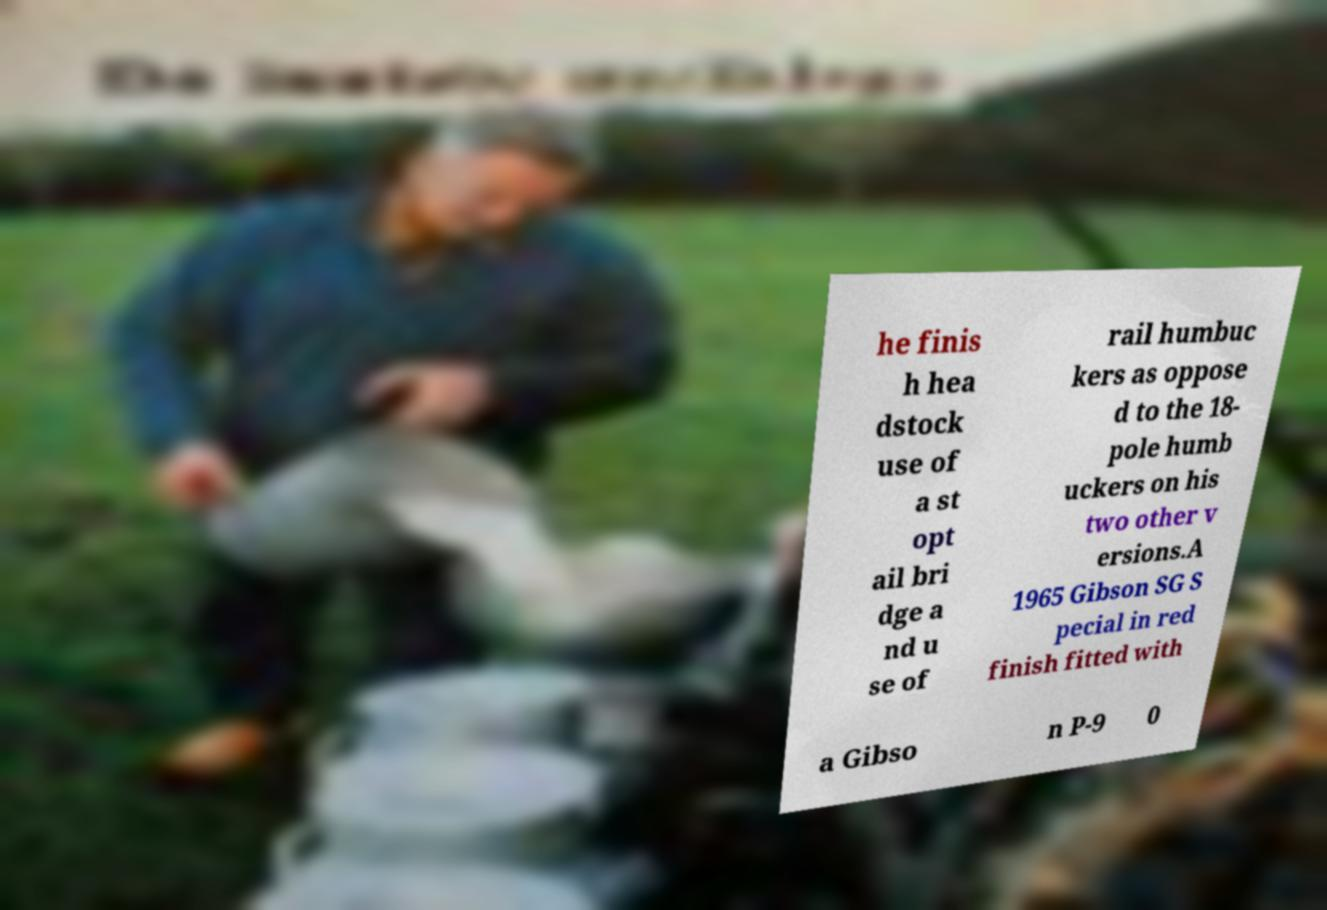I need the written content from this picture converted into text. Can you do that? he finis h hea dstock use of a st opt ail bri dge a nd u se of rail humbuc kers as oppose d to the 18- pole humb uckers on his two other v ersions.A 1965 Gibson SG S pecial in red finish fitted with a Gibso n P-9 0 